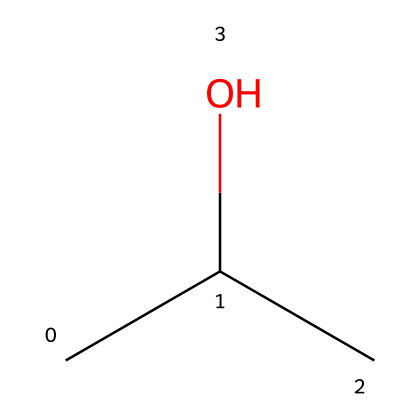What is the chemical name of this compound? The SMILES representation "CC(C)O" corresponds to isopropyl alcohol, which is a common cleaning agent. The structure has three carbon atoms with a hydroxyl group indicating it is an alcohol.
Answer: isopropyl alcohol How many carbon atoms are present in this structure? By examining the SMILES code "CC(C)", we see there are three carbon (C) atoms present. Each 'C' indicates a carbon atom, and the structure shows three total carbons.
Answer: three What functional group is present in this molecule? The presence of the "O" in the SMILES "CC(C)O" indicates that there is a hydroxyl (-OH) group, which is a characteristic functional group of alcohols.
Answer: hydroxyl group What type of alcohol is represented by this structure? The structure "CC(C)O" has a central carbon atom bonded to two other carbon atoms and one hydroxyl group, classifying it as a secondary alcohol.
Answer: secondary alcohol What is the degree of branching in this chemical structure? The SMILES "CC(C)O" depicts a branched structure, as there are three carbon atoms in total with one carbon acting as a branch attached to the central carbon atom.
Answer: branched Is this compound flammable? Isopropyl alcohol, as represented in the SMILES "CC(C)O", is known to be flammable due to the presence of the hydrocarbon chain and the hydroxyl group that can easily ignite.
Answer: yes 